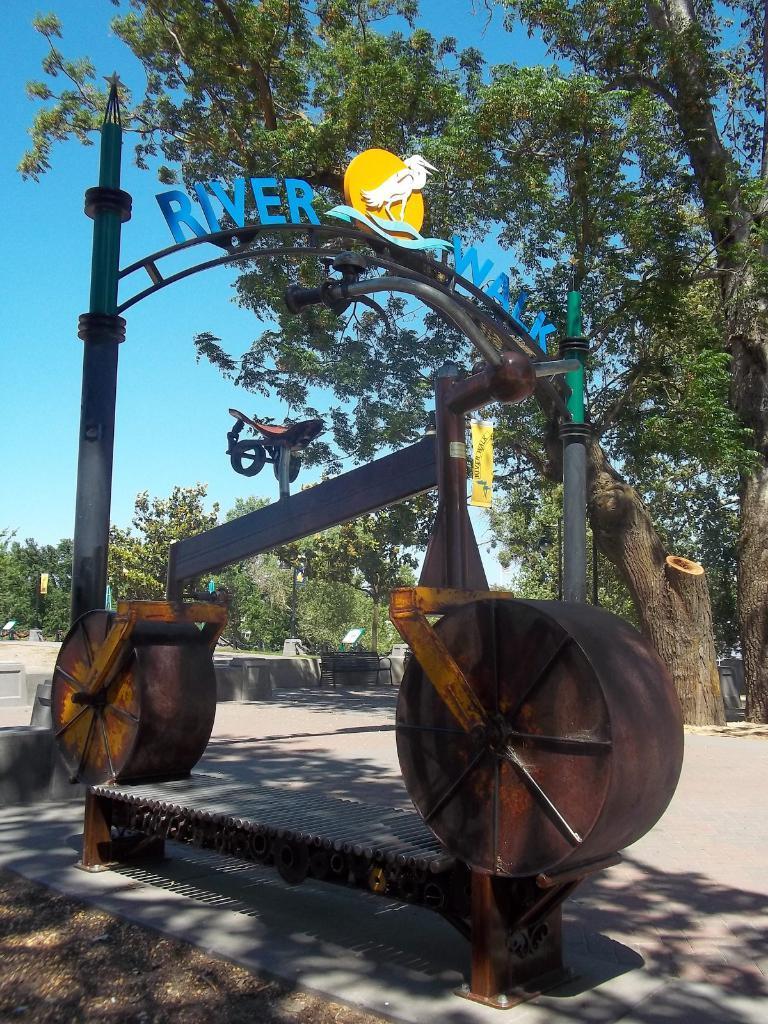In one or two sentences, can you explain what this image depicts? In this image, we can see a bicycle made with iron scraps. At the bottom, there is the path. In the background, we can see larch, trees, boards, bench and sky. 